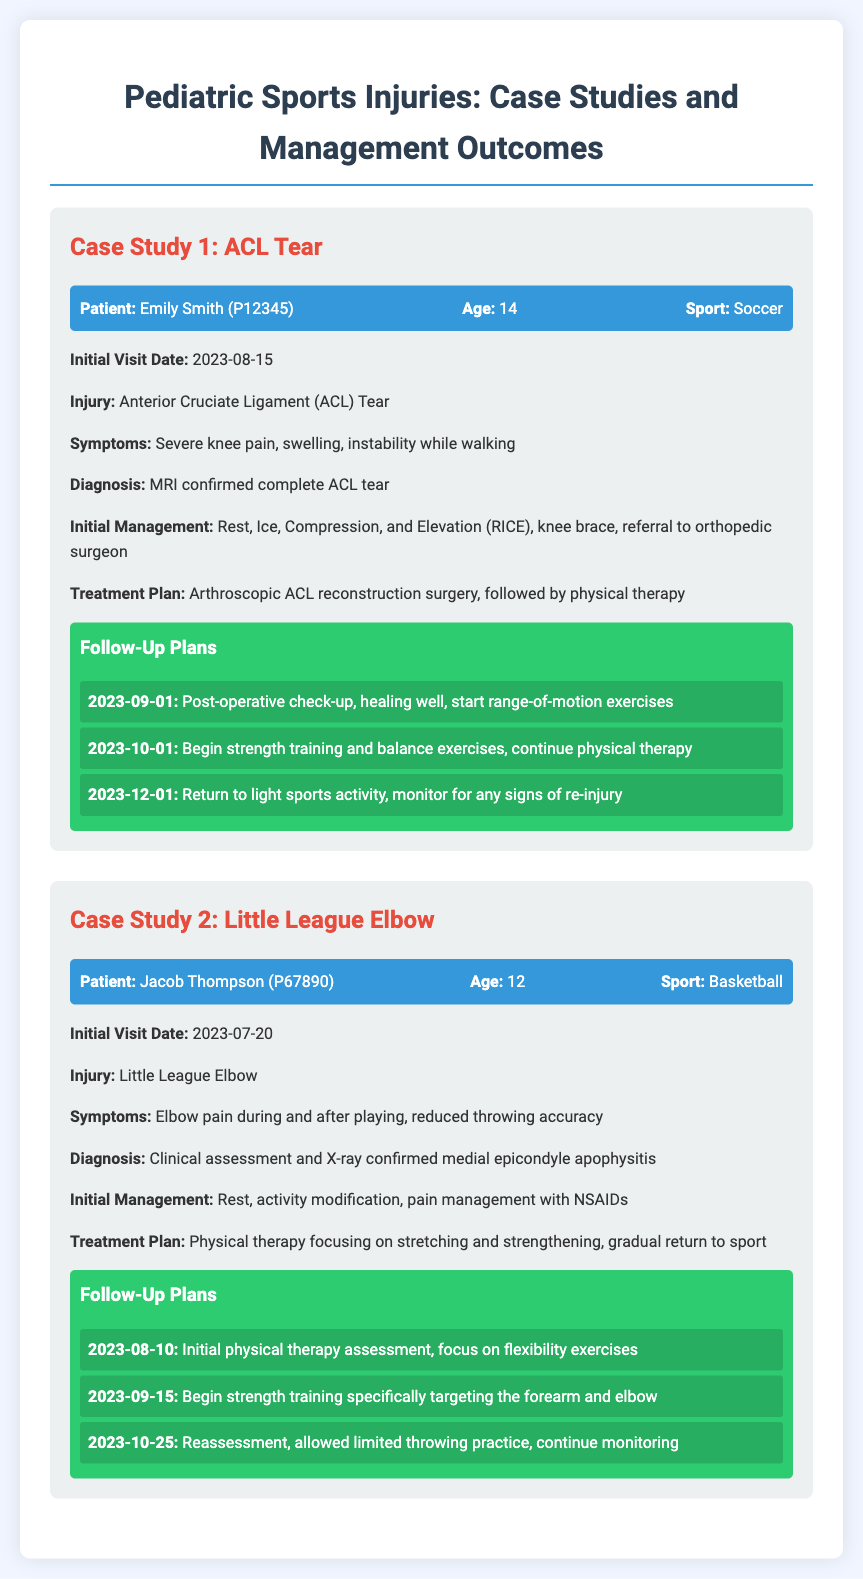What is the patient's name in Case Study 1? The patient in Case Study 1 is named Emily Smith, as stated in the document.
Answer: Emily Smith What sport is Emily Smith involved in? Emily Smith is involved in soccer, which is mentioned in her patient information.
Answer: Soccer What is Jacob Thompson's age? Jacob Thompson's age is provided in his patient information, stating he is 12 years old.
Answer: 12 What injury did Jacob Thompson suffer from? Jacob Thompson suffered from Little League Elbow, as mentioned under his case study.
Answer: Little League Elbow What treatment plan was suggested for Emily Smith? The treatment plan for Emily Smith includes arthroscopic ACL reconstruction surgery followed by physical therapy, as detailed in the document.
Answer: Arthroscopic ACL reconstruction surgery, physical therapy What was Jacob Thompson's initial management? Jacob Thompson's initial management was rest, activity modification, and pain management with NSAIDs, as stated in the case study.
Answer: Rest, activity modification, pain management with NSAIDs On what date was Emily Smith's initial visit? Emily Smith's initial visit date is noted as August 15, 2023, in her case details.
Answer: 2023-08-15 What follow-up date is scheduled for Jacob Thompson to start strength training? The follow-up date for Jacob Thompson to start strength training is September 15, 2023, mentioned in the follow-up plans.
Answer: 2023-09-15 What is the diagnosis for Emily Smith's injury? Emily Smith's diagnosis is a complete ACL tear, which is confirmed by an MRI according to the document.
Answer: Complete ACL tear 